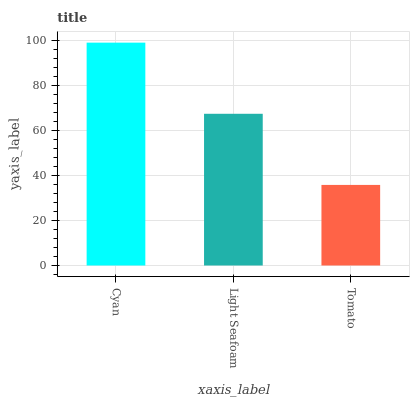Is Tomato the minimum?
Answer yes or no. Yes. Is Cyan the maximum?
Answer yes or no. Yes. Is Light Seafoam the minimum?
Answer yes or no. No. Is Light Seafoam the maximum?
Answer yes or no. No. Is Cyan greater than Light Seafoam?
Answer yes or no. Yes. Is Light Seafoam less than Cyan?
Answer yes or no. Yes. Is Light Seafoam greater than Cyan?
Answer yes or no. No. Is Cyan less than Light Seafoam?
Answer yes or no. No. Is Light Seafoam the high median?
Answer yes or no. Yes. Is Light Seafoam the low median?
Answer yes or no. Yes. Is Tomato the high median?
Answer yes or no. No. Is Cyan the low median?
Answer yes or no. No. 